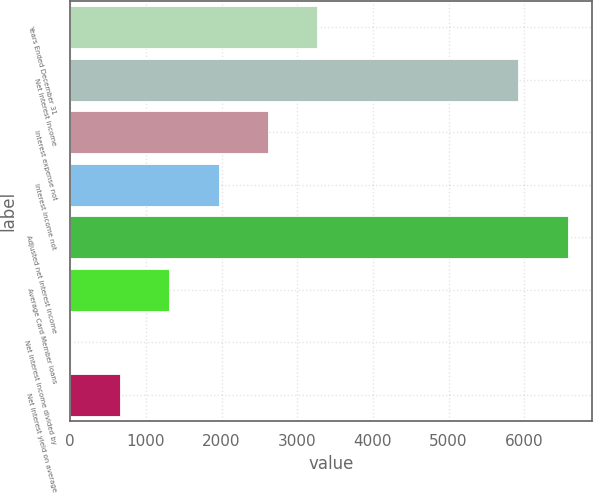<chart> <loc_0><loc_0><loc_500><loc_500><bar_chart><fcel>Years Ended December 31<fcel>Net interest income<fcel>Interest expense not<fcel>Interest income not<fcel>Adjusted net interest income<fcel>Average Card Member loans<fcel>Net interest income divided by<fcel>Net interest yield on average<nl><fcel>3262.8<fcel>5922<fcel>2611.96<fcel>1961.12<fcel>6572.84<fcel>1310.28<fcel>8.6<fcel>659.44<nl></chart> 